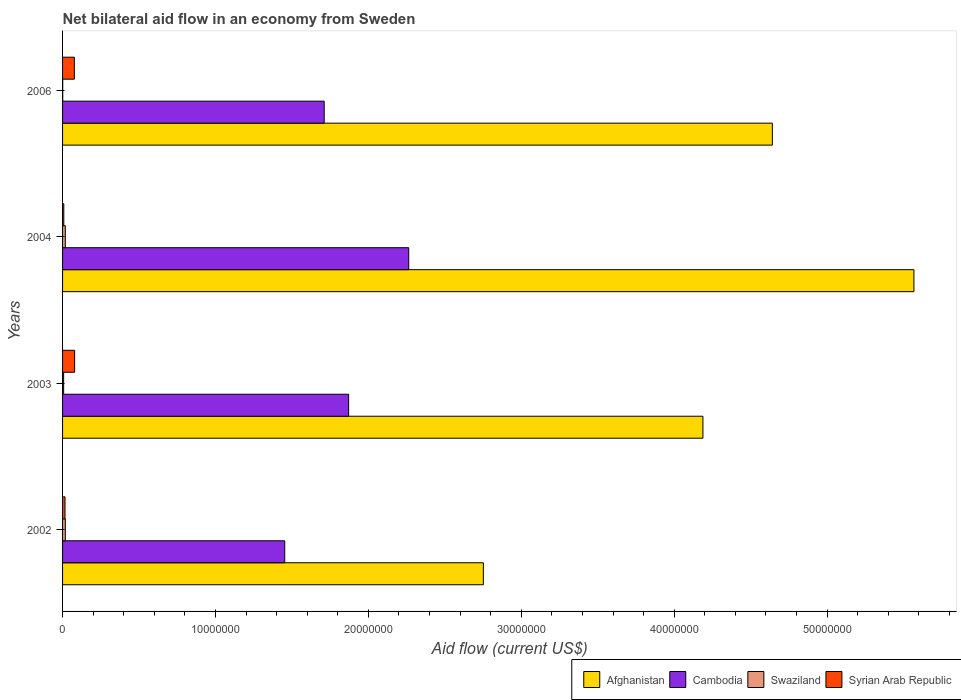How many groups of bars are there?
Offer a very short reply. 4. Are the number of bars on each tick of the Y-axis equal?
Make the answer very short. Yes. How many bars are there on the 3rd tick from the top?
Make the answer very short. 4. How many bars are there on the 3rd tick from the bottom?
Your answer should be compact. 4. What is the net bilateral aid flow in Afghanistan in 2003?
Offer a terse response. 4.19e+07. Across all years, what is the maximum net bilateral aid flow in Afghanistan?
Your answer should be compact. 5.57e+07. Across all years, what is the minimum net bilateral aid flow in Cambodia?
Your answer should be compact. 1.45e+07. In which year was the net bilateral aid flow in Afghanistan maximum?
Ensure brevity in your answer.  2004. What is the total net bilateral aid flow in Syrian Arab Republic in the graph?
Ensure brevity in your answer.  1.80e+06. What is the difference between the net bilateral aid flow in Swaziland in 2003 and that in 2004?
Offer a terse response. -1.10e+05. What is the difference between the net bilateral aid flow in Cambodia in 2003 and the net bilateral aid flow in Syrian Arab Republic in 2002?
Give a very brief answer. 1.86e+07. What is the average net bilateral aid flow in Afghanistan per year?
Keep it short and to the point. 4.29e+07. In the year 2006, what is the difference between the net bilateral aid flow in Syrian Arab Republic and net bilateral aid flow in Cambodia?
Provide a short and direct response. -1.63e+07. In how many years, is the net bilateral aid flow in Afghanistan greater than 46000000 US$?
Offer a terse response. 2. What is the ratio of the net bilateral aid flow in Cambodia in 2004 to that in 2006?
Provide a succinct answer. 1.32. Is the difference between the net bilateral aid flow in Syrian Arab Republic in 2002 and 2003 greater than the difference between the net bilateral aid flow in Cambodia in 2002 and 2003?
Keep it short and to the point. Yes. What is the difference between the highest and the second highest net bilateral aid flow in Cambodia?
Your answer should be compact. 3.93e+06. In how many years, is the net bilateral aid flow in Syrian Arab Republic greater than the average net bilateral aid flow in Syrian Arab Republic taken over all years?
Provide a short and direct response. 2. Is it the case that in every year, the sum of the net bilateral aid flow in Cambodia and net bilateral aid flow in Afghanistan is greater than the sum of net bilateral aid flow in Syrian Arab Republic and net bilateral aid flow in Swaziland?
Offer a terse response. Yes. What does the 1st bar from the top in 2002 represents?
Your answer should be very brief. Syrian Arab Republic. What does the 2nd bar from the bottom in 2006 represents?
Ensure brevity in your answer.  Cambodia. Is it the case that in every year, the sum of the net bilateral aid flow in Cambodia and net bilateral aid flow in Syrian Arab Republic is greater than the net bilateral aid flow in Swaziland?
Offer a terse response. Yes. How many bars are there?
Offer a very short reply. 16. Are all the bars in the graph horizontal?
Make the answer very short. Yes. What is the difference between two consecutive major ticks on the X-axis?
Offer a terse response. 1.00e+07. Are the values on the major ticks of X-axis written in scientific E-notation?
Your answer should be compact. No. Does the graph contain grids?
Your answer should be compact. No. How many legend labels are there?
Provide a short and direct response. 4. What is the title of the graph?
Give a very brief answer. Net bilateral aid flow in an economy from Sweden. What is the label or title of the Y-axis?
Ensure brevity in your answer.  Years. What is the Aid flow (current US$) of Afghanistan in 2002?
Your answer should be compact. 2.75e+07. What is the Aid flow (current US$) of Cambodia in 2002?
Offer a terse response. 1.45e+07. What is the Aid flow (current US$) in Afghanistan in 2003?
Offer a very short reply. 4.19e+07. What is the Aid flow (current US$) of Cambodia in 2003?
Provide a short and direct response. 1.87e+07. What is the Aid flow (current US$) in Syrian Arab Republic in 2003?
Give a very brief answer. 7.90e+05. What is the Aid flow (current US$) of Afghanistan in 2004?
Your answer should be very brief. 5.57e+07. What is the Aid flow (current US$) in Cambodia in 2004?
Ensure brevity in your answer.  2.26e+07. What is the Aid flow (current US$) of Swaziland in 2004?
Keep it short and to the point. 1.80e+05. What is the Aid flow (current US$) in Syrian Arab Republic in 2004?
Your response must be concise. 8.00e+04. What is the Aid flow (current US$) in Afghanistan in 2006?
Offer a terse response. 4.64e+07. What is the Aid flow (current US$) in Cambodia in 2006?
Ensure brevity in your answer.  1.71e+07. What is the Aid flow (current US$) of Swaziland in 2006?
Make the answer very short. 10000. What is the Aid flow (current US$) in Syrian Arab Republic in 2006?
Ensure brevity in your answer.  7.70e+05. Across all years, what is the maximum Aid flow (current US$) of Afghanistan?
Make the answer very short. 5.57e+07. Across all years, what is the maximum Aid flow (current US$) in Cambodia?
Offer a terse response. 2.26e+07. Across all years, what is the maximum Aid flow (current US$) in Syrian Arab Republic?
Your answer should be compact. 7.90e+05. Across all years, what is the minimum Aid flow (current US$) of Afghanistan?
Offer a terse response. 2.75e+07. Across all years, what is the minimum Aid flow (current US$) of Cambodia?
Offer a terse response. 1.45e+07. Across all years, what is the minimum Aid flow (current US$) in Swaziland?
Provide a short and direct response. 10000. What is the total Aid flow (current US$) of Afghanistan in the graph?
Offer a terse response. 1.72e+08. What is the total Aid flow (current US$) of Cambodia in the graph?
Ensure brevity in your answer.  7.30e+07. What is the total Aid flow (current US$) in Swaziland in the graph?
Provide a succinct answer. 4.40e+05. What is the total Aid flow (current US$) of Syrian Arab Republic in the graph?
Offer a very short reply. 1.80e+06. What is the difference between the Aid flow (current US$) in Afghanistan in 2002 and that in 2003?
Make the answer very short. -1.44e+07. What is the difference between the Aid flow (current US$) in Cambodia in 2002 and that in 2003?
Ensure brevity in your answer.  -4.18e+06. What is the difference between the Aid flow (current US$) in Syrian Arab Republic in 2002 and that in 2003?
Your answer should be very brief. -6.30e+05. What is the difference between the Aid flow (current US$) of Afghanistan in 2002 and that in 2004?
Offer a terse response. -2.82e+07. What is the difference between the Aid flow (current US$) of Cambodia in 2002 and that in 2004?
Offer a very short reply. -8.11e+06. What is the difference between the Aid flow (current US$) in Swaziland in 2002 and that in 2004?
Keep it short and to the point. 0. What is the difference between the Aid flow (current US$) in Syrian Arab Republic in 2002 and that in 2004?
Make the answer very short. 8.00e+04. What is the difference between the Aid flow (current US$) of Afghanistan in 2002 and that in 2006?
Your answer should be compact. -1.89e+07. What is the difference between the Aid flow (current US$) of Cambodia in 2002 and that in 2006?
Keep it short and to the point. -2.58e+06. What is the difference between the Aid flow (current US$) of Syrian Arab Republic in 2002 and that in 2006?
Ensure brevity in your answer.  -6.10e+05. What is the difference between the Aid flow (current US$) in Afghanistan in 2003 and that in 2004?
Give a very brief answer. -1.38e+07. What is the difference between the Aid flow (current US$) of Cambodia in 2003 and that in 2004?
Keep it short and to the point. -3.93e+06. What is the difference between the Aid flow (current US$) of Syrian Arab Republic in 2003 and that in 2004?
Offer a very short reply. 7.10e+05. What is the difference between the Aid flow (current US$) of Afghanistan in 2003 and that in 2006?
Provide a short and direct response. -4.54e+06. What is the difference between the Aid flow (current US$) of Cambodia in 2003 and that in 2006?
Your answer should be very brief. 1.60e+06. What is the difference between the Aid flow (current US$) of Afghanistan in 2004 and that in 2006?
Keep it short and to the point. 9.26e+06. What is the difference between the Aid flow (current US$) in Cambodia in 2004 and that in 2006?
Make the answer very short. 5.53e+06. What is the difference between the Aid flow (current US$) in Swaziland in 2004 and that in 2006?
Ensure brevity in your answer.  1.70e+05. What is the difference between the Aid flow (current US$) of Syrian Arab Republic in 2004 and that in 2006?
Provide a short and direct response. -6.90e+05. What is the difference between the Aid flow (current US$) of Afghanistan in 2002 and the Aid flow (current US$) of Cambodia in 2003?
Make the answer very short. 8.81e+06. What is the difference between the Aid flow (current US$) of Afghanistan in 2002 and the Aid flow (current US$) of Swaziland in 2003?
Your response must be concise. 2.74e+07. What is the difference between the Aid flow (current US$) in Afghanistan in 2002 and the Aid flow (current US$) in Syrian Arab Republic in 2003?
Offer a very short reply. 2.67e+07. What is the difference between the Aid flow (current US$) of Cambodia in 2002 and the Aid flow (current US$) of Swaziland in 2003?
Give a very brief answer. 1.45e+07. What is the difference between the Aid flow (current US$) in Cambodia in 2002 and the Aid flow (current US$) in Syrian Arab Republic in 2003?
Ensure brevity in your answer.  1.37e+07. What is the difference between the Aid flow (current US$) of Swaziland in 2002 and the Aid flow (current US$) of Syrian Arab Republic in 2003?
Your response must be concise. -6.10e+05. What is the difference between the Aid flow (current US$) in Afghanistan in 2002 and the Aid flow (current US$) in Cambodia in 2004?
Your response must be concise. 4.88e+06. What is the difference between the Aid flow (current US$) in Afghanistan in 2002 and the Aid flow (current US$) in Swaziland in 2004?
Give a very brief answer. 2.73e+07. What is the difference between the Aid flow (current US$) of Afghanistan in 2002 and the Aid flow (current US$) of Syrian Arab Republic in 2004?
Provide a succinct answer. 2.74e+07. What is the difference between the Aid flow (current US$) in Cambodia in 2002 and the Aid flow (current US$) in Swaziland in 2004?
Offer a very short reply. 1.44e+07. What is the difference between the Aid flow (current US$) in Cambodia in 2002 and the Aid flow (current US$) in Syrian Arab Republic in 2004?
Offer a terse response. 1.44e+07. What is the difference between the Aid flow (current US$) of Swaziland in 2002 and the Aid flow (current US$) of Syrian Arab Republic in 2004?
Offer a very short reply. 1.00e+05. What is the difference between the Aid flow (current US$) of Afghanistan in 2002 and the Aid flow (current US$) of Cambodia in 2006?
Give a very brief answer. 1.04e+07. What is the difference between the Aid flow (current US$) of Afghanistan in 2002 and the Aid flow (current US$) of Swaziland in 2006?
Provide a short and direct response. 2.75e+07. What is the difference between the Aid flow (current US$) of Afghanistan in 2002 and the Aid flow (current US$) of Syrian Arab Republic in 2006?
Keep it short and to the point. 2.68e+07. What is the difference between the Aid flow (current US$) in Cambodia in 2002 and the Aid flow (current US$) in Swaziland in 2006?
Provide a short and direct response. 1.45e+07. What is the difference between the Aid flow (current US$) of Cambodia in 2002 and the Aid flow (current US$) of Syrian Arab Republic in 2006?
Provide a short and direct response. 1.38e+07. What is the difference between the Aid flow (current US$) of Swaziland in 2002 and the Aid flow (current US$) of Syrian Arab Republic in 2006?
Offer a very short reply. -5.90e+05. What is the difference between the Aid flow (current US$) of Afghanistan in 2003 and the Aid flow (current US$) of Cambodia in 2004?
Offer a terse response. 1.92e+07. What is the difference between the Aid flow (current US$) in Afghanistan in 2003 and the Aid flow (current US$) in Swaziland in 2004?
Provide a short and direct response. 4.17e+07. What is the difference between the Aid flow (current US$) in Afghanistan in 2003 and the Aid flow (current US$) in Syrian Arab Republic in 2004?
Make the answer very short. 4.18e+07. What is the difference between the Aid flow (current US$) of Cambodia in 2003 and the Aid flow (current US$) of Swaziland in 2004?
Your response must be concise. 1.85e+07. What is the difference between the Aid flow (current US$) in Cambodia in 2003 and the Aid flow (current US$) in Syrian Arab Republic in 2004?
Provide a succinct answer. 1.86e+07. What is the difference between the Aid flow (current US$) in Afghanistan in 2003 and the Aid flow (current US$) in Cambodia in 2006?
Keep it short and to the point. 2.48e+07. What is the difference between the Aid flow (current US$) of Afghanistan in 2003 and the Aid flow (current US$) of Swaziland in 2006?
Ensure brevity in your answer.  4.19e+07. What is the difference between the Aid flow (current US$) of Afghanistan in 2003 and the Aid flow (current US$) of Syrian Arab Republic in 2006?
Ensure brevity in your answer.  4.11e+07. What is the difference between the Aid flow (current US$) of Cambodia in 2003 and the Aid flow (current US$) of Swaziland in 2006?
Ensure brevity in your answer.  1.87e+07. What is the difference between the Aid flow (current US$) in Cambodia in 2003 and the Aid flow (current US$) in Syrian Arab Republic in 2006?
Provide a short and direct response. 1.79e+07. What is the difference between the Aid flow (current US$) of Swaziland in 2003 and the Aid flow (current US$) of Syrian Arab Republic in 2006?
Provide a short and direct response. -7.00e+05. What is the difference between the Aid flow (current US$) of Afghanistan in 2004 and the Aid flow (current US$) of Cambodia in 2006?
Provide a short and direct response. 3.86e+07. What is the difference between the Aid flow (current US$) of Afghanistan in 2004 and the Aid flow (current US$) of Swaziland in 2006?
Offer a terse response. 5.57e+07. What is the difference between the Aid flow (current US$) of Afghanistan in 2004 and the Aid flow (current US$) of Syrian Arab Republic in 2006?
Keep it short and to the point. 5.49e+07. What is the difference between the Aid flow (current US$) of Cambodia in 2004 and the Aid flow (current US$) of Swaziland in 2006?
Provide a succinct answer. 2.26e+07. What is the difference between the Aid flow (current US$) of Cambodia in 2004 and the Aid flow (current US$) of Syrian Arab Republic in 2006?
Provide a short and direct response. 2.19e+07. What is the difference between the Aid flow (current US$) in Swaziland in 2004 and the Aid flow (current US$) in Syrian Arab Republic in 2006?
Your answer should be very brief. -5.90e+05. What is the average Aid flow (current US$) in Afghanistan per year?
Ensure brevity in your answer.  4.29e+07. What is the average Aid flow (current US$) in Cambodia per year?
Make the answer very short. 1.82e+07. What is the average Aid flow (current US$) in Syrian Arab Republic per year?
Make the answer very short. 4.50e+05. In the year 2002, what is the difference between the Aid flow (current US$) of Afghanistan and Aid flow (current US$) of Cambodia?
Your answer should be compact. 1.30e+07. In the year 2002, what is the difference between the Aid flow (current US$) of Afghanistan and Aid flow (current US$) of Swaziland?
Offer a very short reply. 2.73e+07. In the year 2002, what is the difference between the Aid flow (current US$) in Afghanistan and Aid flow (current US$) in Syrian Arab Republic?
Offer a terse response. 2.74e+07. In the year 2002, what is the difference between the Aid flow (current US$) of Cambodia and Aid flow (current US$) of Swaziland?
Ensure brevity in your answer.  1.44e+07. In the year 2002, what is the difference between the Aid flow (current US$) in Cambodia and Aid flow (current US$) in Syrian Arab Republic?
Keep it short and to the point. 1.44e+07. In the year 2002, what is the difference between the Aid flow (current US$) of Swaziland and Aid flow (current US$) of Syrian Arab Republic?
Your answer should be very brief. 2.00e+04. In the year 2003, what is the difference between the Aid flow (current US$) of Afghanistan and Aid flow (current US$) of Cambodia?
Offer a very short reply. 2.32e+07. In the year 2003, what is the difference between the Aid flow (current US$) in Afghanistan and Aid flow (current US$) in Swaziland?
Keep it short and to the point. 4.18e+07. In the year 2003, what is the difference between the Aid flow (current US$) in Afghanistan and Aid flow (current US$) in Syrian Arab Republic?
Ensure brevity in your answer.  4.11e+07. In the year 2003, what is the difference between the Aid flow (current US$) of Cambodia and Aid flow (current US$) of Swaziland?
Make the answer very short. 1.86e+07. In the year 2003, what is the difference between the Aid flow (current US$) of Cambodia and Aid flow (current US$) of Syrian Arab Republic?
Offer a very short reply. 1.79e+07. In the year 2003, what is the difference between the Aid flow (current US$) of Swaziland and Aid flow (current US$) of Syrian Arab Republic?
Offer a terse response. -7.20e+05. In the year 2004, what is the difference between the Aid flow (current US$) of Afghanistan and Aid flow (current US$) of Cambodia?
Make the answer very short. 3.30e+07. In the year 2004, what is the difference between the Aid flow (current US$) of Afghanistan and Aid flow (current US$) of Swaziland?
Ensure brevity in your answer.  5.55e+07. In the year 2004, what is the difference between the Aid flow (current US$) of Afghanistan and Aid flow (current US$) of Syrian Arab Republic?
Keep it short and to the point. 5.56e+07. In the year 2004, what is the difference between the Aid flow (current US$) in Cambodia and Aid flow (current US$) in Swaziland?
Provide a short and direct response. 2.25e+07. In the year 2004, what is the difference between the Aid flow (current US$) in Cambodia and Aid flow (current US$) in Syrian Arab Republic?
Give a very brief answer. 2.26e+07. In the year 2004, what is the difference between the Aid flow (current US$) in Swaziland and Aid flow (current US$) in Syrian Arab Republic?
Offer a terse response. 1.00e+05. In the year 2006, what is the difference between the Aid flow (current US$) of Afghanistan and Aid flow (current US$) of Cambodia?
Offer a very short reply. 2.93e+07. In the year 2006, what is the difference between the Aid flow (current US$) in Afghanistan and Aid flow (current US$) in Swaziland?
Provide a succinct answer. 4.64e+07. In the year 2006, what is the difference between the Aid flow (current US$) of Afghanistan and Aid flow (current US$) of Syrian Arab Republic?
Ensure brevity in your answer.  4.56e+07. In the year 2006, what is the difference between the Aid flow (current US$) of Cambodia and Aid flow (current US$) of Swaziland?
Provide a short and direct response. 1.71e+07. In the year 2006, what is the difference between the Aid flow (current US$) in Cambodia and Aid flow (current US$) in Syrian Arab Republic?
Your response must be concise. 1.63e+07. In the year 2006, what is the difference between the Aid flow (current US$) of Swaziland and Aid flow (current US$) of Syrian Arab Republic?
Offer a very short reply. -7.60e+05. What is the ratio of the Aid flow (current US$) in Afghanistan in 2002 to that in 2003?
Your answer should be very brief. 0.66. What is the ratio of the Aid flow (current US$) of Cambodia in 2002 to that in 2003?
Give a very brief answer. 0.78. What is the ratio of the Aid flow (current US$) of Swaziland in 2002 to that in 2003?
Provide a short and direct response. 2.57. What is the ratio of the Aid flow (current US$) in Syrian Arab Republic in 2002 to that in 2003?
Give a very brief answer. 0.2. What is the ratio of the Aid flow (current US$) of Afghanistan in 2002 to that in 2004?
Offer a terse response. 0.49. What is the ratio of the Aid flow (current US$) of Cambodia in 2002 to that in 2004?
Offer a terse response. 0.64. What is the ratio of the Aid flow (current US$) of Syrian Arab Republic in 2002 to that in 2004?
Give a very brief answer. 2. What is the ratio of the Aid flow (current US$) of Afghanistan in 2002 to that in 2006?
Keep it short and to the point. 0.59. What is the ratio of the Aid flow (current US$) of Cambodia in 2002 to that in 2006?
Provide a succinct answer. 0.85. What is the ratio of the Aid flow (current US$) of Syrian Arab Republic in 2002 to that in 2006?
Provide a succinct answer. 0.21. What is the ratio of the Aid flow (current US$) in Afghanistan in 2003 to that in 2004?
Give a very brief answer. 0.75. What is the ratio of the Aid flow (current US$) of Cambodia in 2003 to that in 2004?
Give a very brief answer. 0.83. What is the ratio of the Aid flow (current US$) of Swaziland in 2003 to that in 2004?
Your answer should be very brief. 0.39. What is the ratio of the Aid flow (current US$) of Syrian Arab Republic in 2003 to that in 2004?
Your response must be concise. 9.88. What is the ratio of the Aid flow (current US$) in Afghanistan in 2003 to that in 2006?
Give a very brief answer. 0.9. What is the ratio of the Aid flow (current US$) of Cambodia in 2003 to that in 2006?
Ensure brevity in your answer.  1.09. What is the ratio of the Aid flow (current US$) in Syrian Arab Republic in 2003 to that in 2006?
Your answer should be compact. 1.03. What is the ratio of the Aid flow (current US$) in Afghanistan in 2004 to that in 2006?
Your response must be concise. 1.2. What is the ratio of the Aid flow (current US$) of Cambodia in 2004 to that in 2006?
Your response must be concise. 1.32. What is the ratio of the Aid flow (current US$) in Swaziland in 2004 to that in 2006?
Ensure brevity in your answer.  18. What is the ratio of the Aid flow (current US$) of Syrian Arab Republic in 2004 to that in 2006?
Ensure brevity in your answer.  0.1. What is the difference between the highest and the second highest Aid flow (current US$) in Afghanistan?
Your answer should be very brief. 9.26e+06. What is the difference between the highest and the second highest Aid flow (current US$) of Cambodia?
Ensure brevity in your answer.  3.93e+06. What is the difference between the highest and the second highest Aid flow (current US$) of Syrian Arab Republic?
Keep it short and to the point. 2.00e+04. What is the difference between the highest and the lowest Aid flow (current US$) in Afghanistan?
Give a very brief answer. 2.82e+07. What is the difference between the highest and the lowest Aid flow (current US$) in Cambodia?
Your response must be concise. 8.11e+06. What is the difference between the highest and the lowest Aid flow (current US$) of Syrian Arab Republic?
Provide a succinct answer. 7.10e+05. 